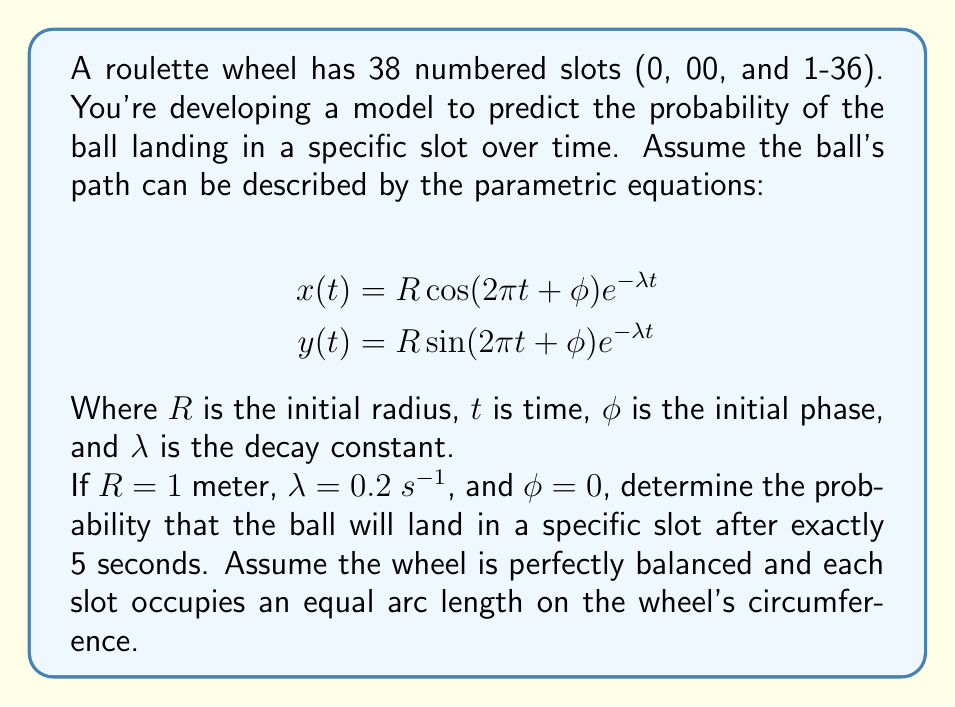Can you answer this question? Let's approach this step-by-step:

1) First, we need to understand what the parametric equations represent. They describe a spiral path that the ball takes as it loses energy and moves towards the center of the wheel.

2) At $t = 5$ seconds, we need to find the radius of the ball's position. This is given by:

   $$r(5) = \sqrt{x(5)^2 + y(5)^2} = Re^{-\lambda t}$$

3) Substituting the values:

   $$r(5) = 1 \cdot e^{-0.2 \cdot 5} = e^{-1} \approx 0.3679$$

4) Now, we need to consider the probability distribution. Since the wheel is perfectly balanced and each slot occupies an equal arc length, the probability of landing in any specific slot is uniform when the ball is at the outermost edge (r = 1).

5) As the ball moves inward, the probability of landing in a specific slot increases proportionally to how close the ball is to the center. This is because the ball has to travel a shorter distance to reach any given slot.

6) The probability of landing in a specific slot is inversely proportional to the circumference of the circle at the current radius. The circumference at time t is $2\pi r(t)$.

7) Therefore, the probability of landing in a specific slot at time t is:

   $$P(t) = \frac{1}{38} \cdot \frac{1}{r(t)}$$

8) Substituting our value for r(5):

   $$P(5) = \frac{1}{38} \cdot \frac{1}{0.3679} \approx 0.0714$$

This means that at exactly 5 seconds, the probability of the ball landing in any specific slot is about 7.14%, which is higher than the initial probability of 1/38 ≈ 2.63% when the ball is at the outer edge.
Answer: The probability of the ball landing in a specific slot after exactly 5 seconds is approximately 0.0714 or 7.14%. 